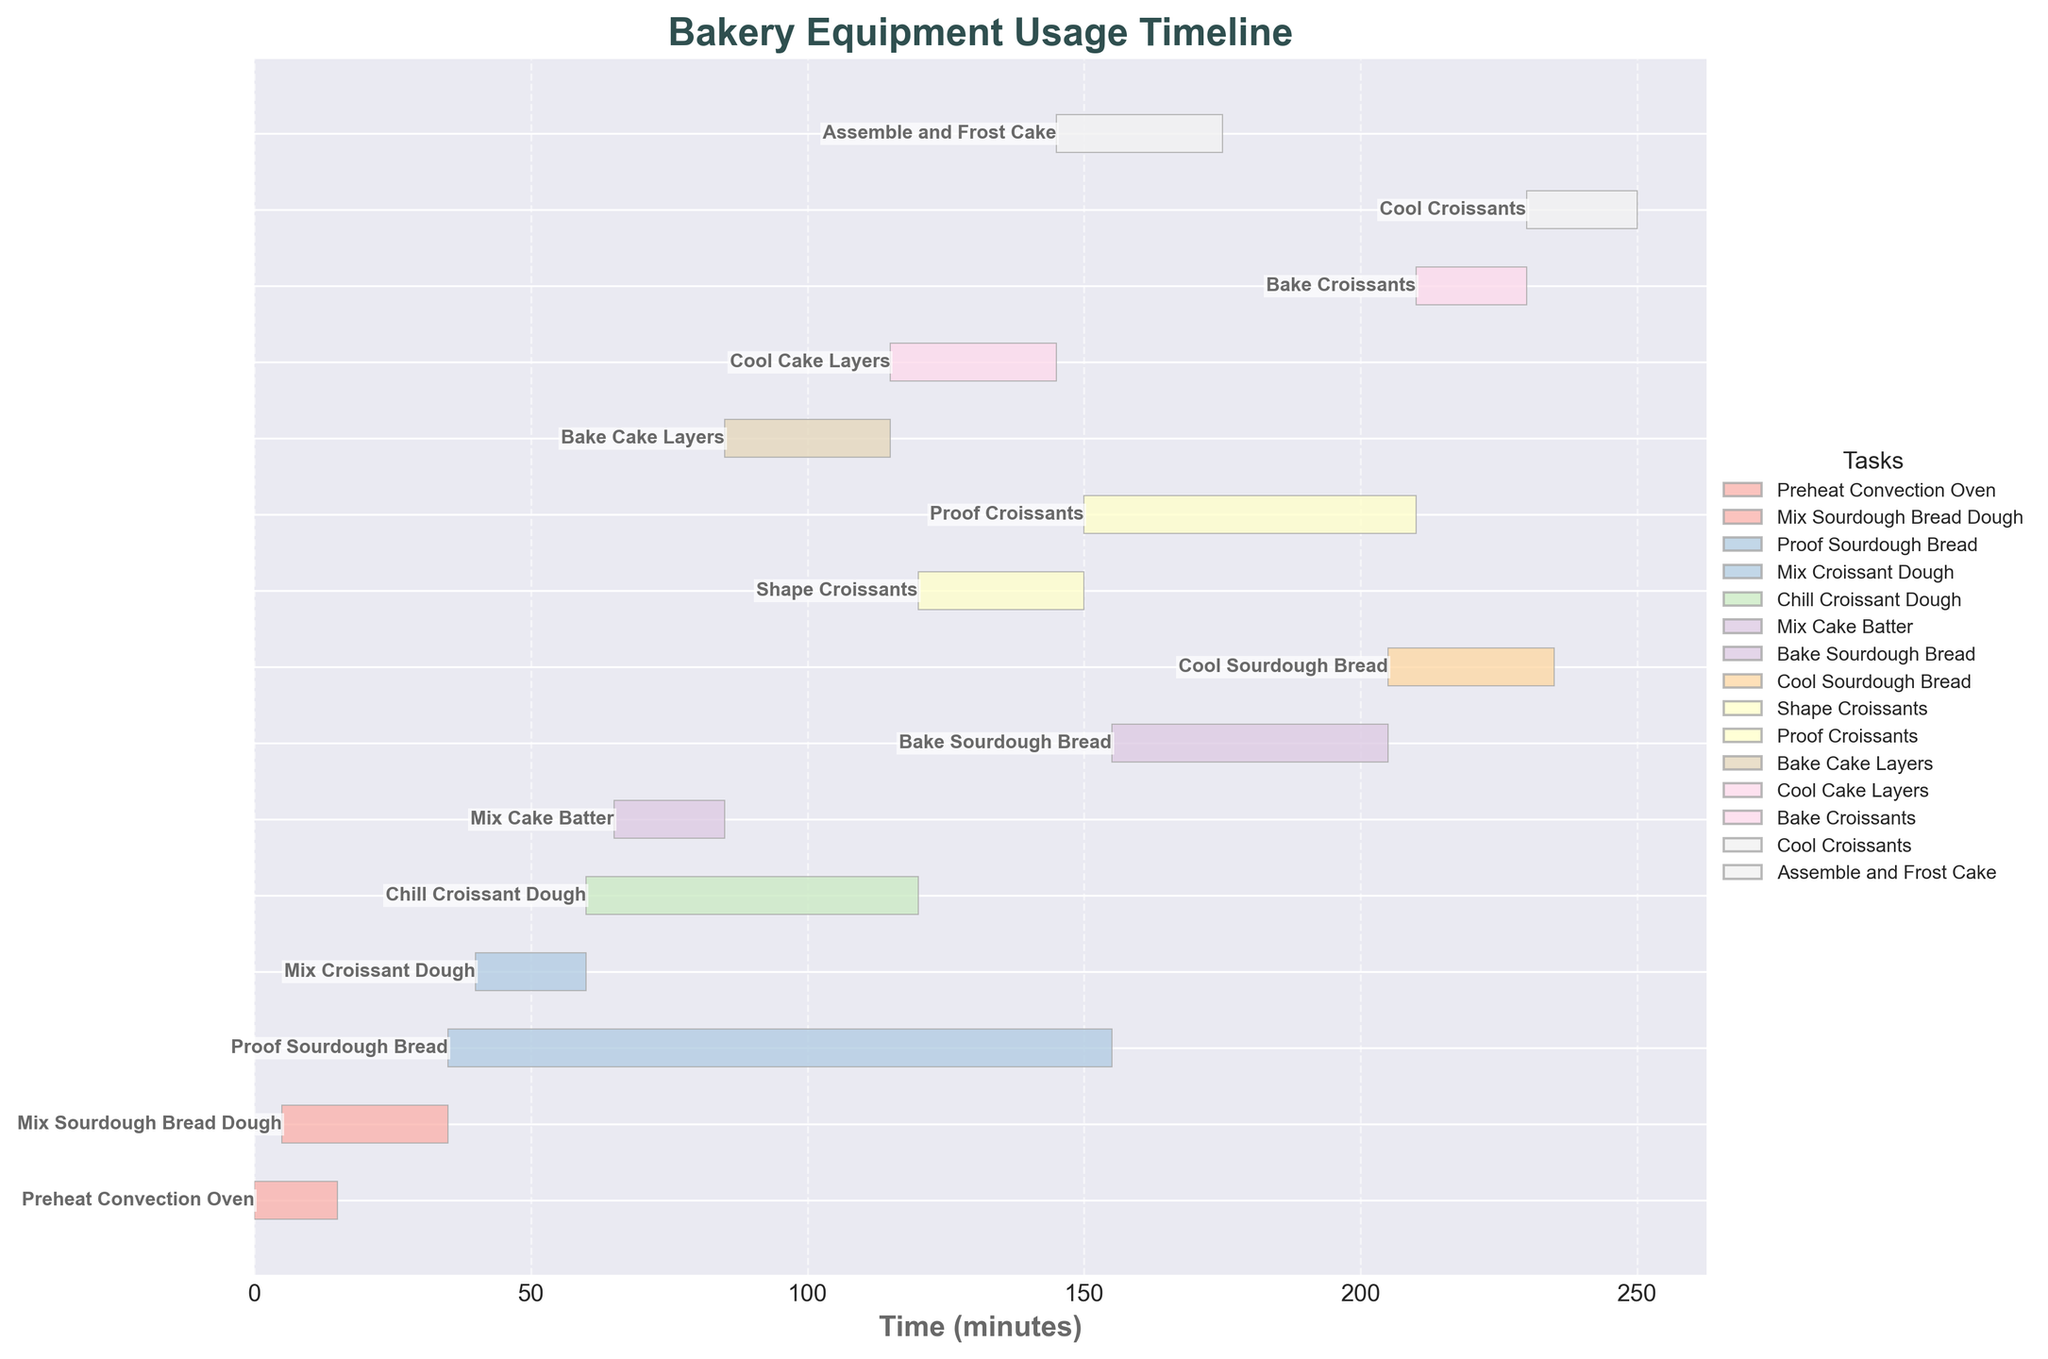What's the title of the chart? The title is shown at the top of the chart and usually gives a brief description of what the chart represents.
Answer: Bakery Equipment Usage Timeline What time interval does the Gantt Chart cover? By looking at the x-axis, which represents time in minutes, we can see that it starts from 0 and ends at around 250 minutes.
Answer: 250 minutes Which task takes the longest time to complete? By examining the lengths of the horizontal bars, the task "Proof Sourdough Bread" is visibly the longest.
Answer: Proof Sourdough Bread How much time is there between the end of "Proof Sourdough Bread" and the start of "Bake Sourdough Bread"? The end time for "Proof Sourdough Bread" is 155 minutes, and the start time for "Bake Sourdough Bread" is the same at 155 minutes.
Answer: 0 minutes Which tasks overlap with "Mix Croissant Dough"? "Mix Croissant Dough" starts at 40 minutes and ends at 60 minutes. Any task within this interval overlaps: "Proof Sourdough Bread" and "Chill Croissant Dough".
Answer: Proof Sourdough Bread, Chill Croissant Dough When can we start "Assemble and Frost Cake"? "Assemble and Frost Cake" can only start after "Bake Cake Layers" and "Cool Cake Layers," which ends at 145 minutes.
Answer: 145 minutes What is the total duration required for mixing tasks (Mix Sourdough Bread Dough, Mix Croissant Dough, and Mix Cake Batter)? Sum up the durations of these mixing tasks. "Mix Sourdough Bread Dough" (35-5=30 minutes), "Mix Croissant Dough" (60-40=20 minutes), "Mix Cake Batter" (85-65=20 minutes). Total = 30+20+20=70 minutes.
Answer: 70 minutes Which task uses the oven immediately before "Bake Croissants"? The task that uses the oven immediately before "Bake Croissants" is "Bake Sourdough Bread", which ends at 205 minutes, followed shortly by "Bake Croissants" starting at 210 minutes.
Answer: Bake Sourdough Bread What is the interval between the end of "Cool Sourdough Bread" and the start of "Shape Croissants"? "Cool Sourdough Bread" ends at 235 minutes, and "Shape Croissants" starts at 120 minutes, thus there’s no waiting period.
Answer: No interval Which tasks use the mixer? The Gantt Chart shows three tasks involving the mixer: "Mix Sourdough Bread Dough", "Mix Croissant Dough", and "Mix Cake Batter".
Answer: Mix Sourdough Bread Dough, Mix Croissant Dough, Mix Cake Batter 